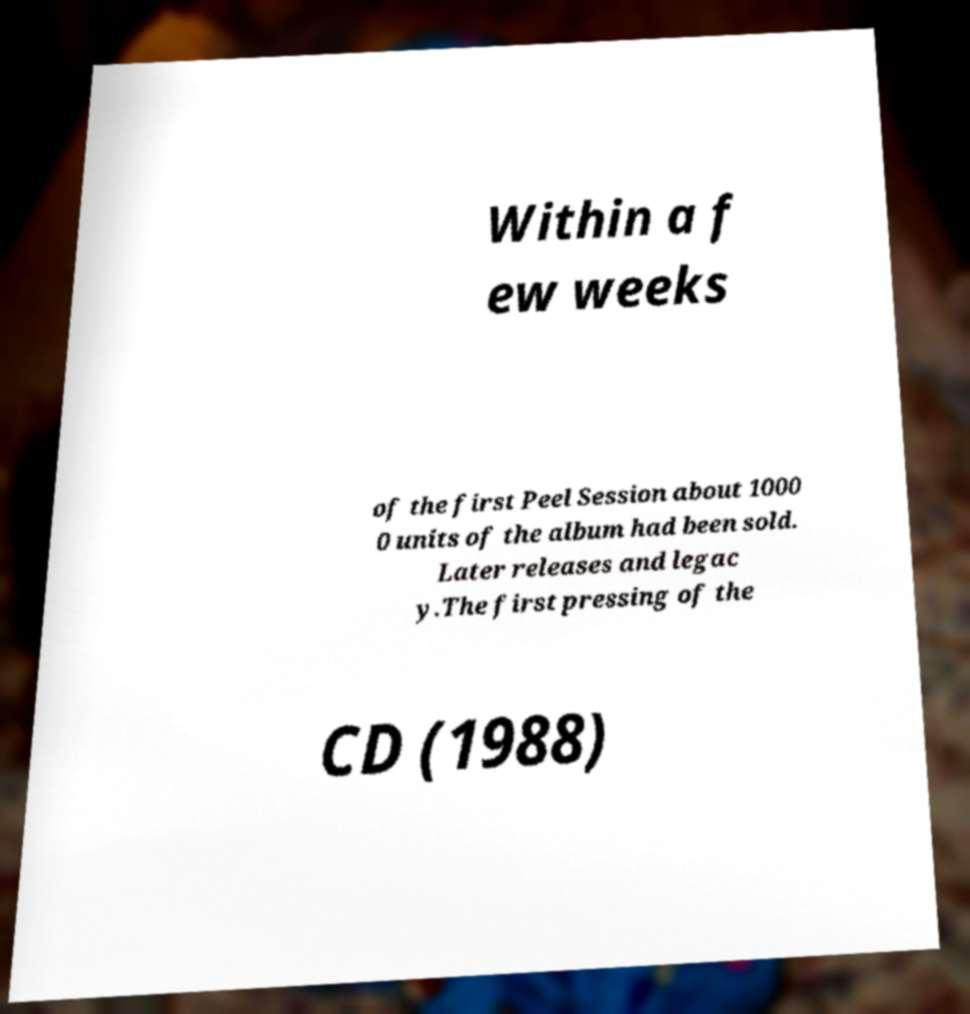For documentation purposes, I need the text within this image transcribed. Could you provide that? Within a f ew weeks of the first Peel Session about 1000 0 units of the album had been sold. Later releases and legac y.The first pressing of the CD (1988) 